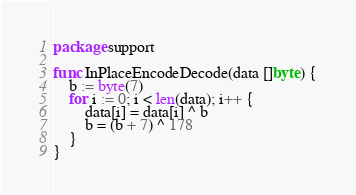Convert code to text. <code><loc_0><loc_0><loc_500><loc_500><_Go_>package support

func InPlaceEncodeDecode(data []byte) {
	b := byte(7)
	for i := 0; i < len(data); i++ {
		data[i] = data[i] ^ b
		b = (b + 7) ^ 178
	}
}
</code> 